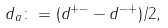<formula> <loc_0><loc_0><loc_500><loc_500>d _ { a } \colon = ( d ^ { + - } - d ^ { - + } ) / 2 ,</formula> 